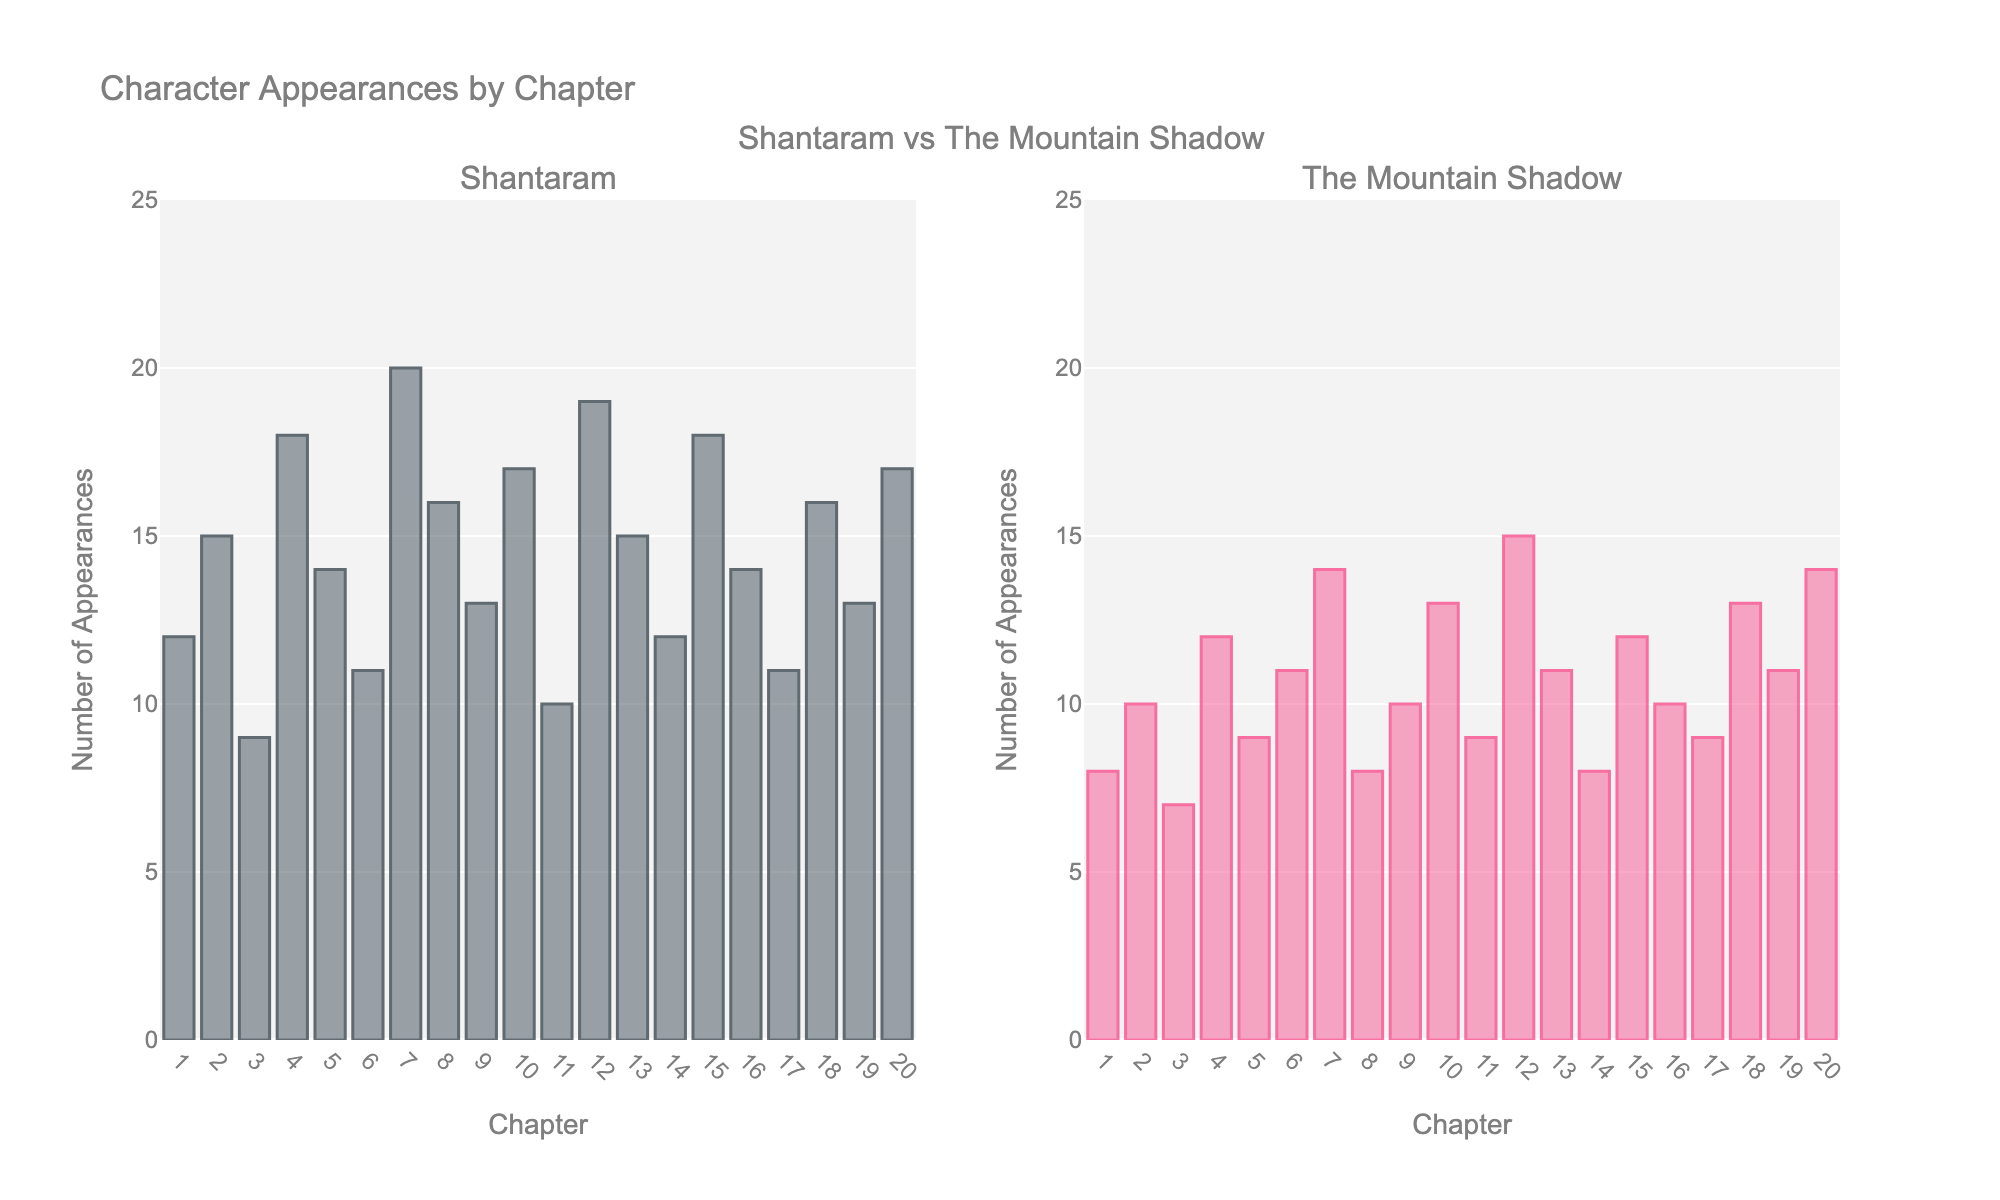What's the difference in character appearances between Chapter 4 in Shantaram and The Mountain Shadow? In Chapter 4, Shantaram has 18 character appearances, while The Mountain Shadow has 12. The difference is 18 - 12 = 6
Answer: 6 Which chapters have equal character appearances in both books? Look for chapters where the bar heights match in both subplots. In Chapter 6, both Shantaram and The Mountain Shadow have 11 appearances.
Answer: Chapter 6 What is the average number of character appearances in Chapter 7 across both books? Sum of appearances in Chapter 7 from both books: Shantaram (20) and The Mountain Shadow (14). The average is (20 + 14) / 2 = 17
Answer: 17 In which chapter does Shantaram have the maximum number of character appearances? Compare the heights of all bars in the Shantaram subplot. Chapter 7 has the tallest bar with 20 appearances.
Answer: Chapter 7 Which book has more character appearances in Chapter 15? Compare the heights of bars in Chapter 15 in both subplots. Shantaram has 18 appearances, whereas The Mountain Shadow has 12. Shantaram has more.
Answer: Shantaram Is there a chapter where The Mountain Shadow has more character appearances than Shantaram? Compare the heights of the bars across both subplots. In Chapter 12, The Mountain Shadow (15) has more appearances than Shantaram (19).
Answer: No How does the number of appearances in Chapter 10 compare between the two books? Check the bar heights for Chapter 10. Shantaram has 17 appearances and The Mountain Shadow has 13. Shantaram has more appearances.
Answer: Shantaram What is the difference in character appearances between the highest and lowest chapters in Shantaram? The highest is Chapter 7 with 20 appearances, and the lowest is Chapter 3 with 9 appearances. The difference is 20 - 9 = 11
Answer: 11 Which chapter has the smallest difference in character appearances between the two books? Calculate the absolute difference for each chapter. Chapter 6 has equal appearances, making the difference 0, which is the smallest possible.
Answer: Chapter 6 